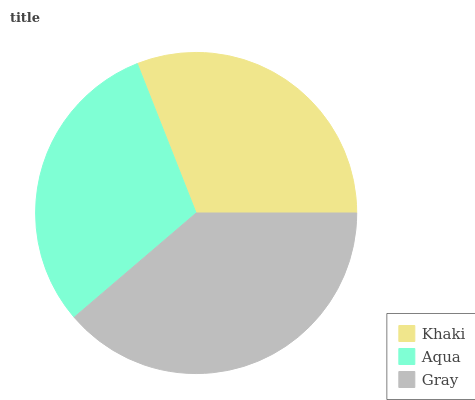Is Aqua the minimum?
Answer yes or no. Yes. Is Gray the maximum?
Answer yes or no. Yes. Is Gray the minimum?
Answer yes or no. No. Is Aqua the maximum?
Answer yes or no. No. Is Gray greater than Aqua?
Answer yes or no. Yes. Is Aqua less than Gray?
Answer yes or no. Yes. Is Aqua greater than Gray?
Answer yes or no. No. Is Gray less than Aqua?
Answer yes or no. No. Is Khaki the high median?
Answer yes or no. Yes. Is Khaki the low median?
Answer yes or no. Yes. Is Gray the high median?
Answer yes or no. No. Is Aqua the low median?
Answer yes or no. No. 